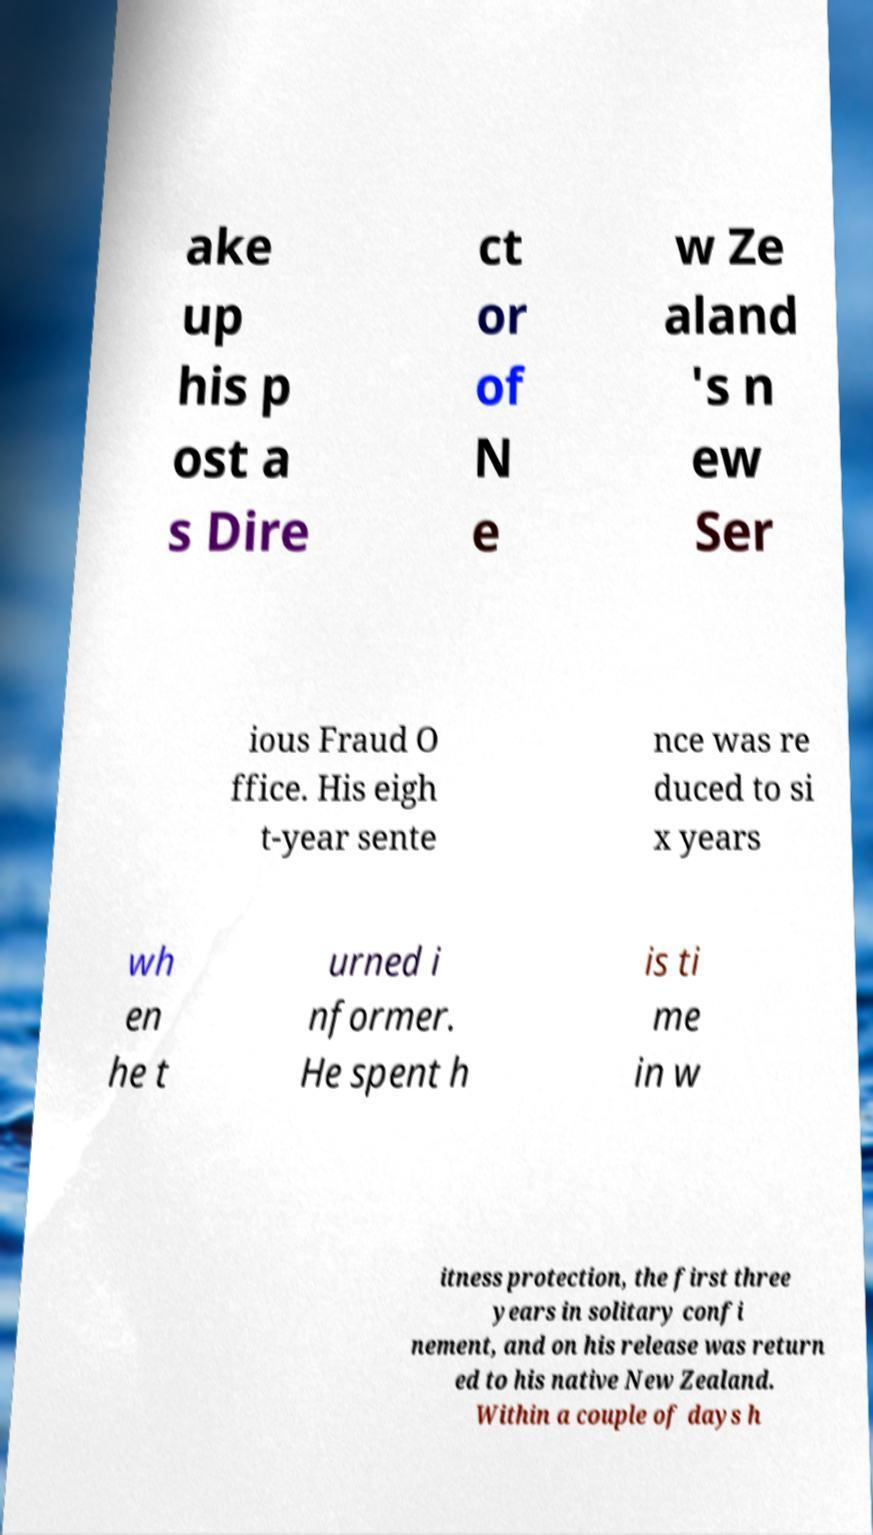There's text embedded in this image that I need extracted. Can you transcribe it verbatim? ake up his p ost a s Dire ct or of N e w Ze aland 's n ew Ser ious Fraud O ffice. His eigh t-year sente nce was re duced to si x years wh en he t urned i nformer. He spent h is ti me in w itness protection, the first three years in solitary confi nement, and on his release was return ed to his native New Zealand. Within a couple of days h 